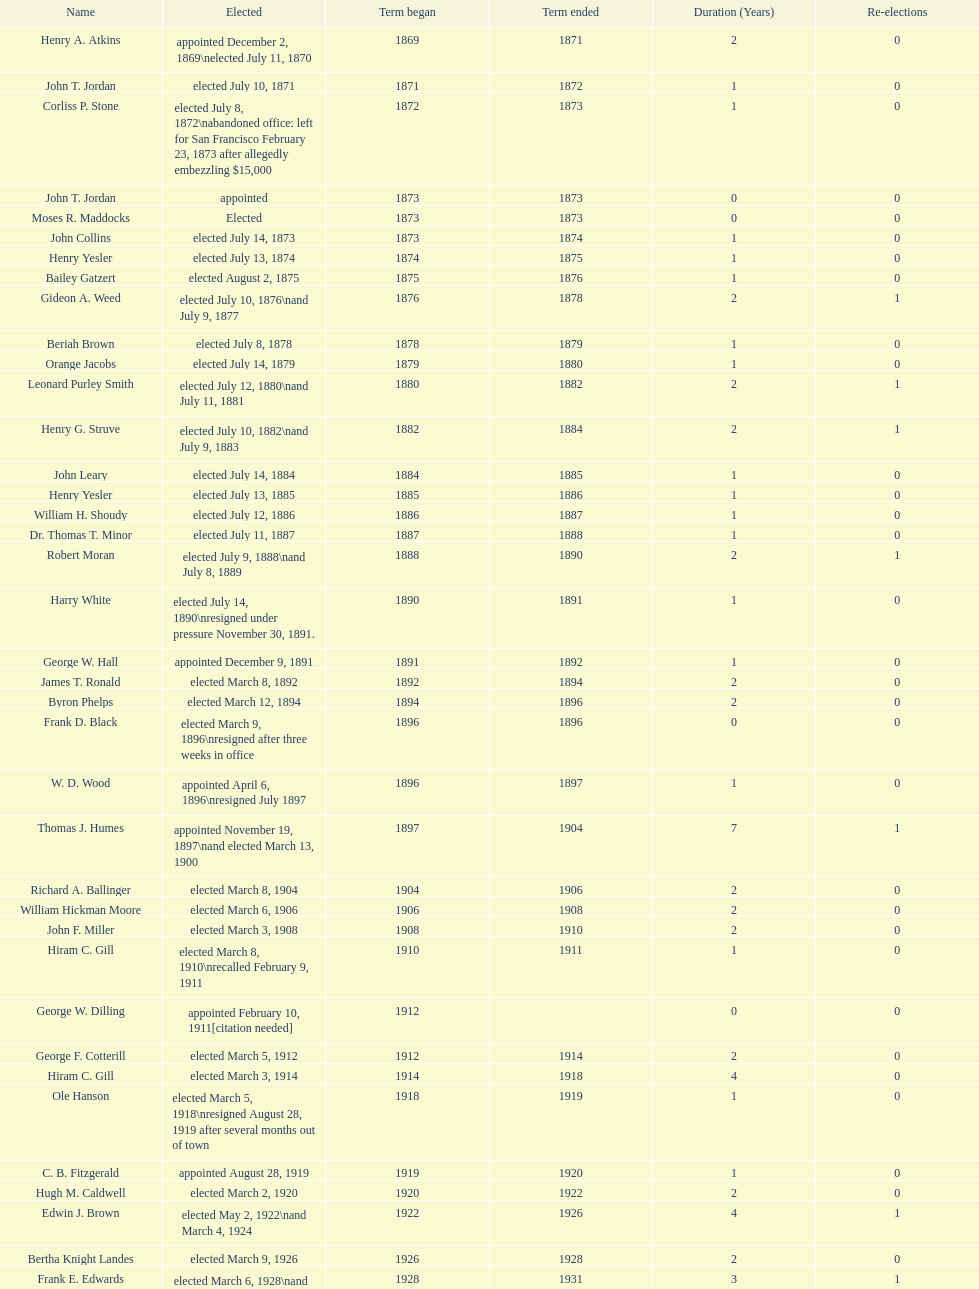Who was the only person elected in 1871? John T. Jordan. 